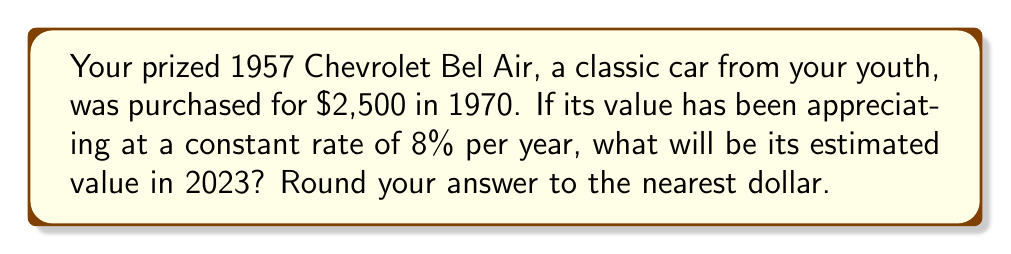Can you solve this math problem? Let's approach this step-by-step using the exponential growth formula:

1) The exponential growth formula is:
   $A = P(1 + r)^t$
   Where:
   $A$ = Final amount
   $P$ = Principal (initial) amount
   $r$ = Annual growth rate (as a decimal)
   $t$ = Time in years

2) We know:
   $P = $2,500 (initial value in 1970)
   $r = 0.08$ (8% written as a decimal)
   $t = 2023 - 1970 = 53$ years

3) Let's plug these values into our formula:
   $A = 2500(1 + 0.08)^{53}$

4) Simplify inside the parentheses:
   $A = 2500(1.08)^{53}$

5) Use a calculator to compute this:
   $A = 2500 * 65.98532...$
   $A = 164,963.30...$

6) Rounding to the nearest dollar:
   $A ≈ $164,963$

Therefore, the estimated value of your 1957 Chevrolet Bel Air in 2023 would be $164,963.
Answer: $164,963 